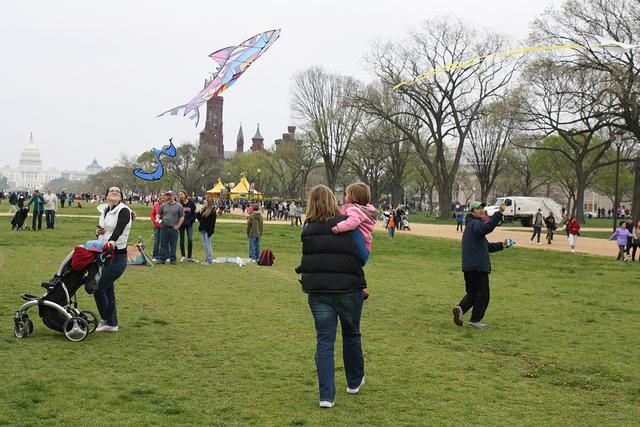What is in the air?
Quick response, please. Kite. How many people are standing?
Quick response, please. 100. Is this a race?
Be succinct. No. What color is the person on the right wearing?
Short answer required. Blue. Is this an airport?
Be succinct. No. Are they all wearing the same jackets?
Write a very short answer. No. Are the people on a sports team?
Keep it brief. No. Is the little girl wearing a dress?
Short answer required. No. What city is this picture taken in?
Short answer required. Washington dc. What is over the girls head?
Be succinct. Kite. What do they have in their hands?
Quick response, please. Kites. Where they playing a sport?
Be succinct. Park. What  are they doing?
Concise answer only. Walking. Is it cloudy?
Keep it brief. Yes. How many granules of dirt on are in this field?
Short answer required. 10000000. What is the woman doing?
Concise answer only. Carrying baby. 